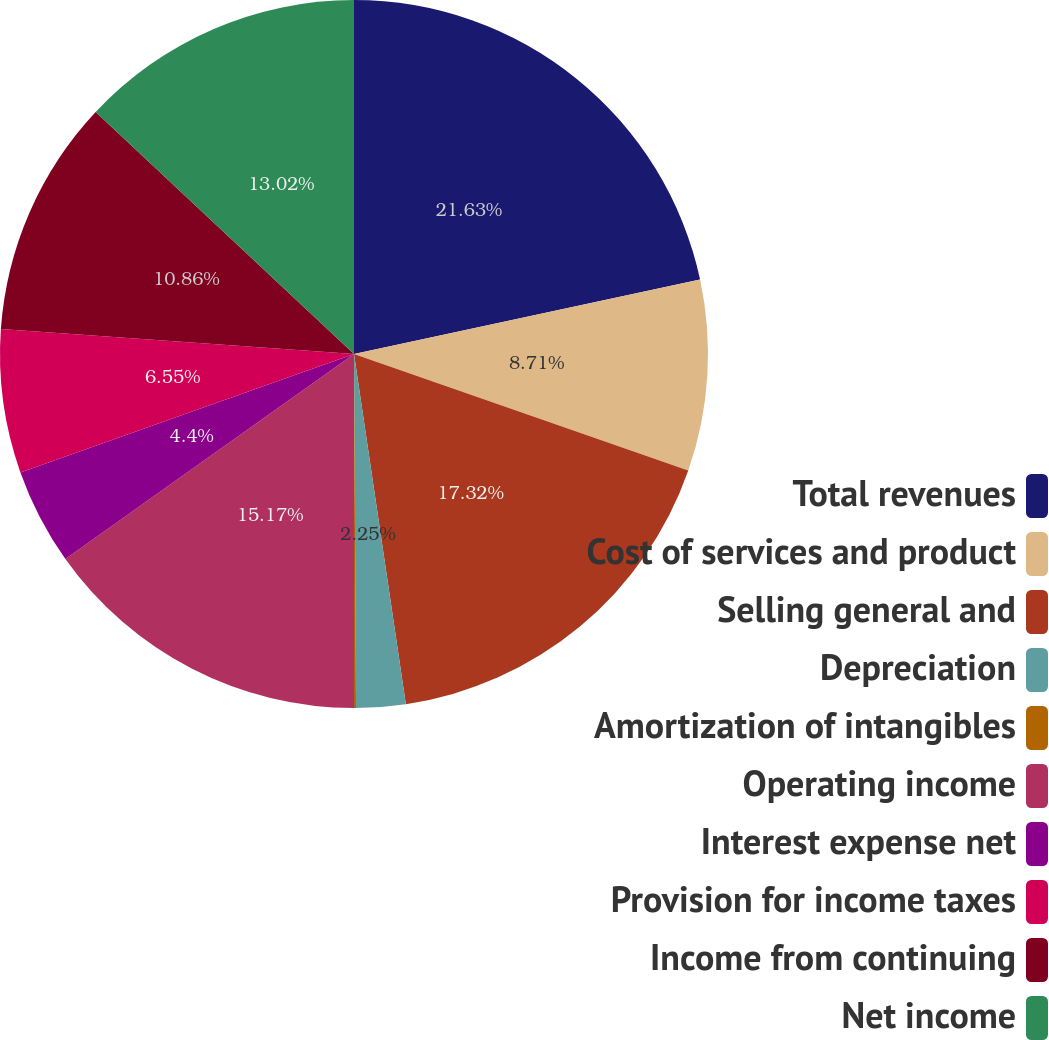<chart> <loc_0><loc_0><loc_500><loc_500><pie_chart><fcel>Total revenues<fcel>Cost of services and product<fcel>Selling general and<fcel>Depreciation<fcel>Amortization of intangibles<fcel>Operating income<fcel>Interest expense net<fcel>Provision for income taxes<fcel>Income from continuing<fcel>Net income<nl><fcel>21.63%<fcel>8.71%<fcel>17.32%<fcel>2.25%<fcel>0.09%<fcel>15.17%<fcel>4.4%<fcel>6.55%<fcel>10.86%<fcel>13.02%<nl></chart> 